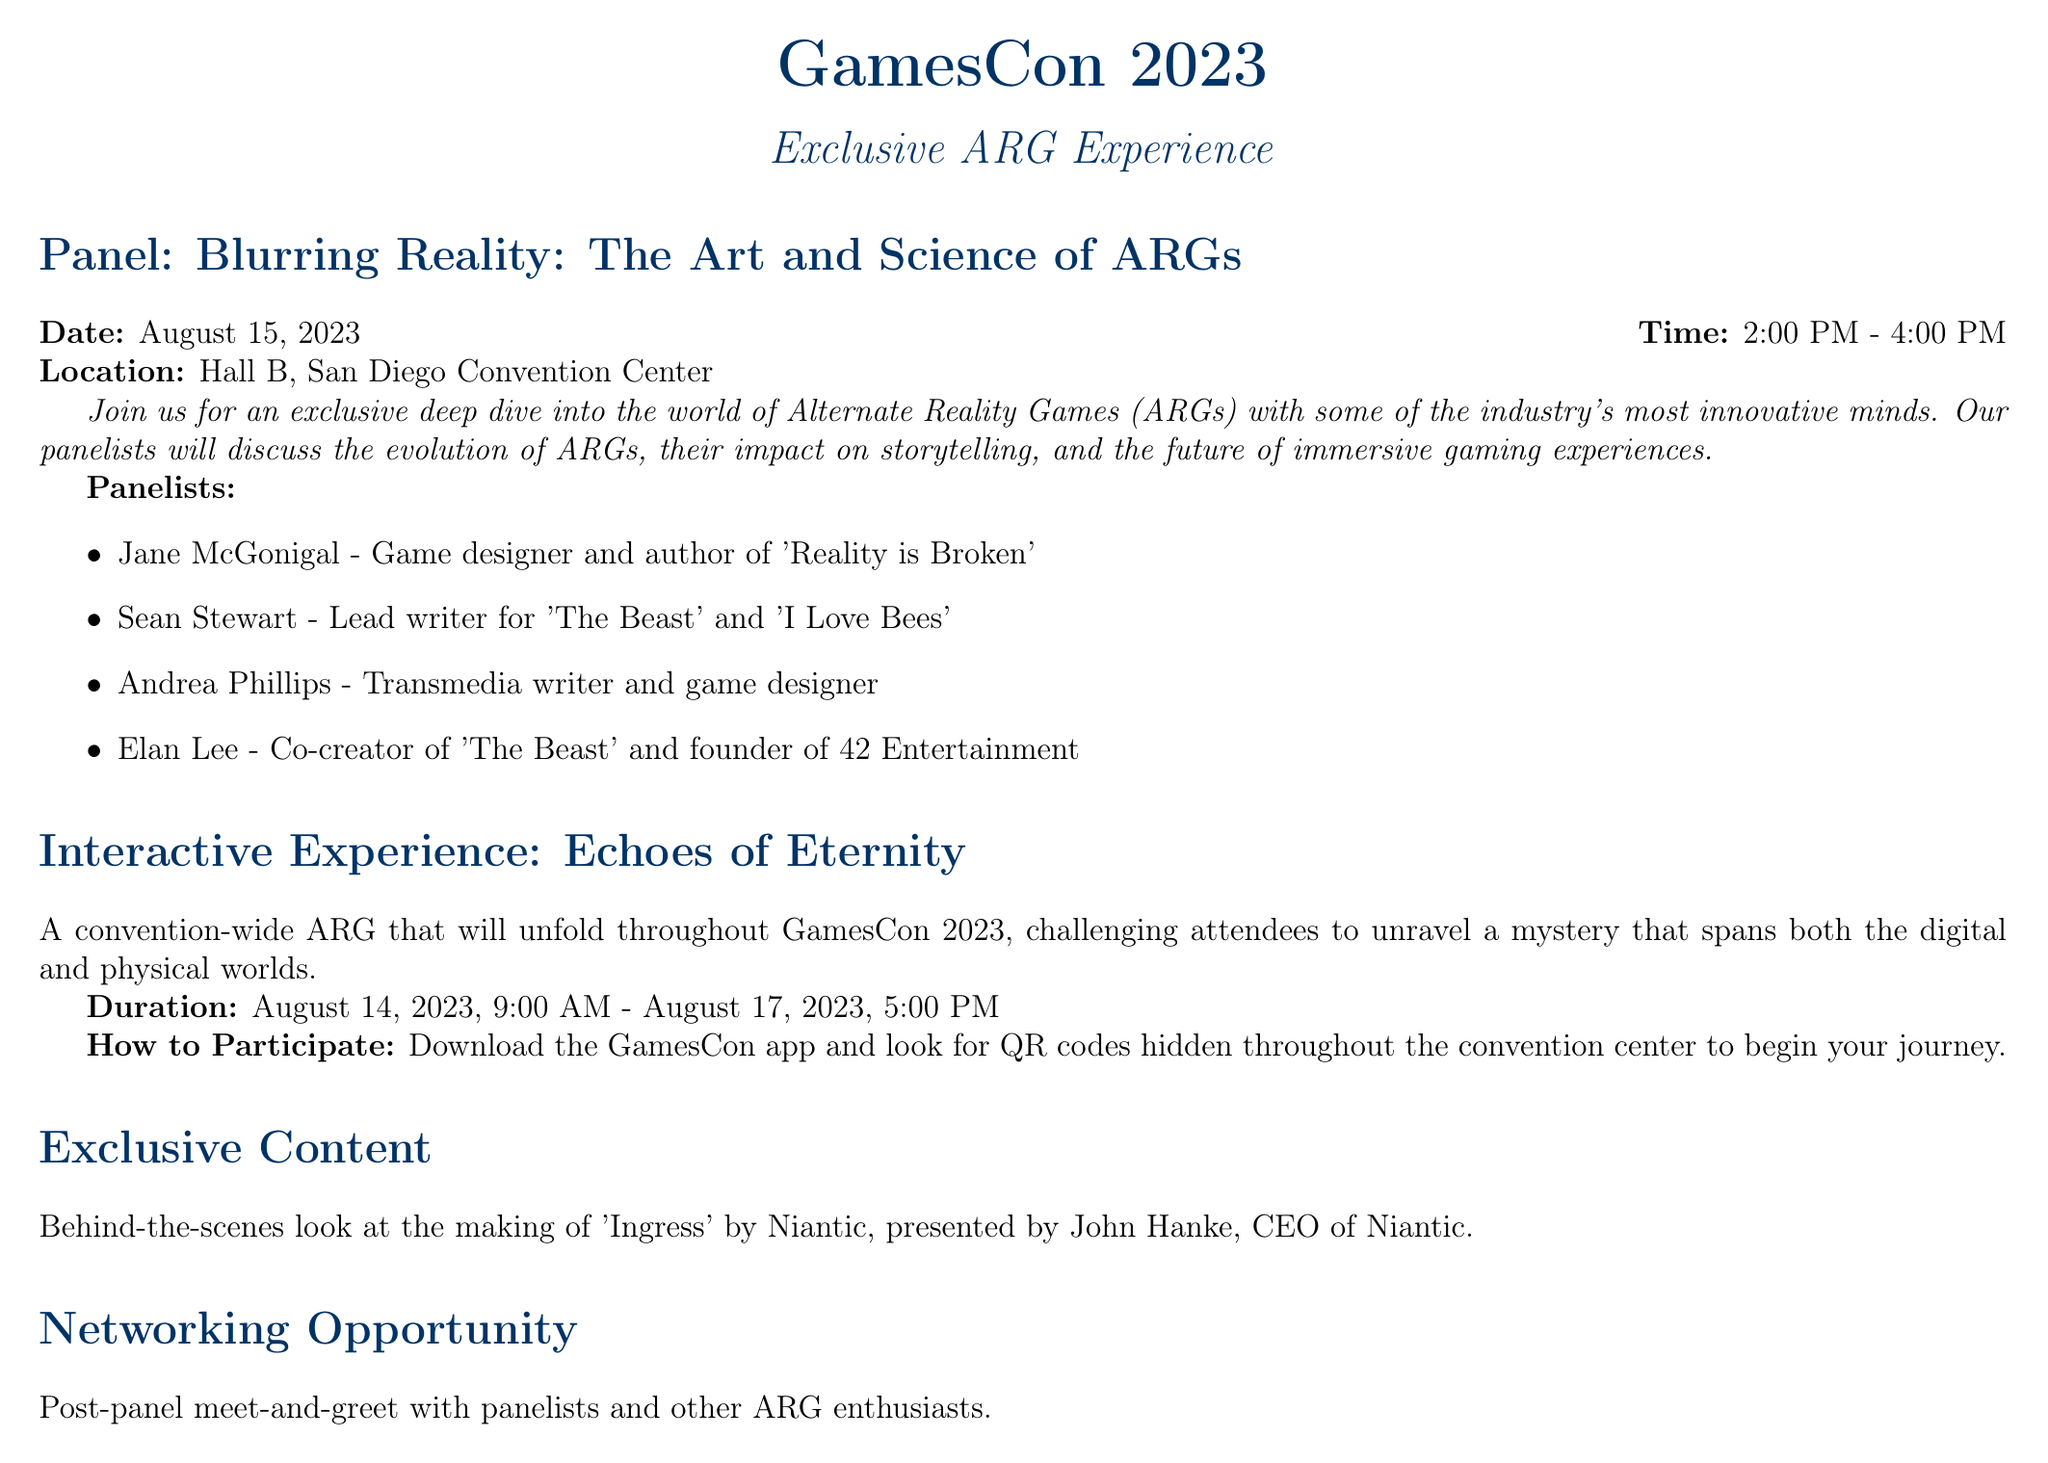What is the name of the convention? The document states the name of the convention, which is the event being described.
Answer: GamesCon 2023 What is the panel's title? The title of the panel discussion is explicitly mentioned in the document.
Answer: Blurring Reality: The Art and Science of ARGs When does the interactive experience start? The start time for the interactive experience is clearly indicated in the details provided.
Answer: August 14, 2023, 9:00 AM Who is the presenter of the exclusive content? The document specifies the name of the person presenting the behind-the-scenes look, which is a key detail.
Answer: John Hanke What are attendees required to bring to the panel? The recommended preparation provides information on what attendees should prepare to participate effectively.
Answer: Fully charged smartphone or tablet How long is the ARG interactive experience? The duration of the interactive experience is defined by its start and end times in the document.
Answer: August 14, 2023, to August 17, 2023 Name one of the panelists. The document lists multiple panelists, but asking for any one of their names is sufficient for an answer.
Answer: Jane McGonigal What is the location of the workshop? The document provides details about related events, specifying where the ARG Design Workshop will be held.
Answer: Room 207, San Diego Convention Center 